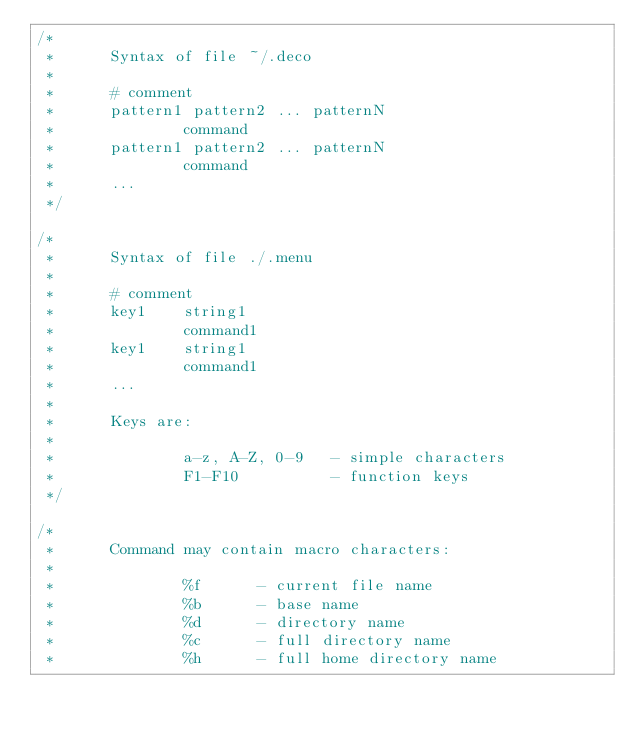<code> <loc_0><loc_0><loc_500><loc_500><_C_>/*
 *      Syntax of file ~/.deco
 *
 *      # comment
 *      pattern1 pattern2 ... patternN
 *              command
 *      pattern1 pattern2 ... patternN
 *              command
 *      ...
 */

/*
 *      Syntax of file ./.menu
 *
 *      # comment
 *      key1    string1
 *              command1
 *      key1    string1
 *              command1
 *      ...
 *
 *      Keys are:
 *
 *              a-z, A-Z, 0-9   - simple characters
 *              F1-F10          - function keys
 */

/*
 *      Command may contain macro characters:
 *
 *              %f      - current file name
 *              %b      - base name
 *              %d      - directory name
 *              %c      - full directory name
 *              %h      - full home directory name</code> 